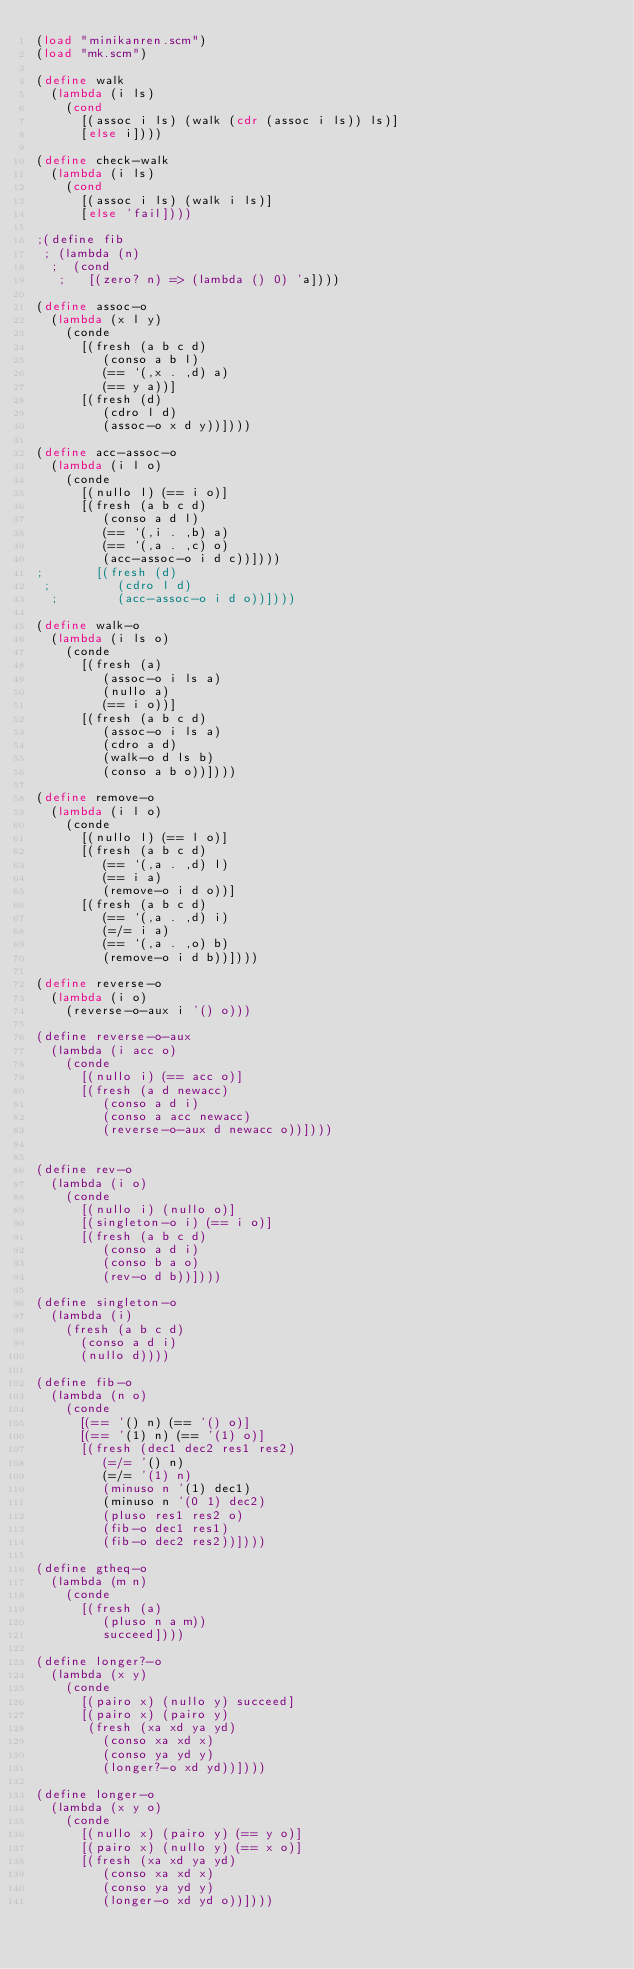<code> <loc_0><loc_0><loc_500><loc_500><_Scheme_>(load "minikanren.scm")
(load "mk.scm")

(define walk
  (lambda (i ls)
    (cond
      [(assoc i ls) (walk (cdr (assoc i ls)) ls)]
      [else i])))

(define check-walk
  (lambda (i ls)
    (cond
      [(assoc i ls) (walk i ls)]
      [else 'fail])))

;(define fib
 ; (lambda (n)
  ;  (cond
   ;   [(zero? n) => (lambda () 0) 'a])))

(define assoc-o
  (lambda (x l y)
    (conde
      [(fresh (a b c d)
         (conso a b l)
         (== `(,x . ,d) a)
         (== y a))]
      [(fresh (d)
         (cdro l d)
         (assoc-o x d y))])))

(define acc-assoc-o
  (lambda (i l o)
    (conde
      [(nullo l) (== i o)]
      [(fresh (a b c d)
         (conso a d l)
         (== `(,i . ,b) a)
         (== `(,a . ,c) o)
         (acc-assoc-o i d c))])))
;       [(fresh (d)
 ;         (cdro l d)
  ;        (acc-assoc-o i d o))])))

(define walk-o
  (lambda (i ls o)
    (conde
      [(fresh (a)
         (assoc-o i ls a)
         (nullo a)
         (== i o))]
      [(fresh (a b c d)
         (assoc-o i ls a)
         (cdro a d)
         (walk-o d ls b)
         (conso a b o))])))

(define remove-o
  (lambda (i l o)
    (conde
      [(nullo l) (== l o)]
      [(fresh (a b c d)
         (== `(,a . ,d) l)
         (== i a)
         (remove-o i d o))]
      [(fresh (a b c d)
         (== `(,a . ,d) i)
         (=/= i a)
         (== `(,a . ,o) b)
         (remove-o i d b))])))

(define reverse-o
  (lambda (i o)
    (reverse-o-aux i '() o)))

(define reverse-o-aux
  (lambda (i acc o)
    (conde
      [(nullo i) (== acc o)]
      [(fresh (a d newacc)
         (conso a d i)
         (conso a acc newacc)
         (reverse-o-aux d newacc o))])))


(define rev-o
  (lambda (i o)
    (conde
      [(nullo i) (nullo o)]
      [(singleton-o i) (== i o)]
      [(fresh (a b c d)
         (conso a d i)
         (conso b a o)
         (rev-o d b))])))
      
(define singleton-o
  (lambda (i)
    (fresh (a b c d)
      (conso a d i)
      (nullo d))))

(define fib-o
  (lambda (n o)
    (conde
      [(== '() n) (== '() o)]
      [(== '(1) n) (== '(1) o)]
      [(fresh (dec1 dec2 res1 res2)
         (=/= '() n)
         (=/= '(1) n)
         (minuso n '(1) dec1)
         (minuso n '(0 1) dec2)
         (pluso res1 res2 o)
         (fib-o dec1 res1)
         (fib-o dec2 res2))])))

(define gtheq-o
  (lambda (m n)
    (conde
      [(fresh (a)
         (pluso n a m))
         succeed])))

(define longer?-o
  (lambda (x y)
    (conde
      [(pairo x) (nullo y) succeed]
      [(pairo x) (pairo y)
       (fresh (xa xd ya yd)
         (conso xa xd x)
         (conso ya yd y)
         (longer?-o xd yd))])))

(define longer-o
  (lambda (x y o)
    (conde
      [(nullo x) (pairo y) (== y o)]
      [(pairo x) (nullo y) (== x o)]
      [(fresh (xa xd ya yd)
         (conso xa xd x)
         (conso ya yd y)
         (longer-o xd yd o))])))
</code> 